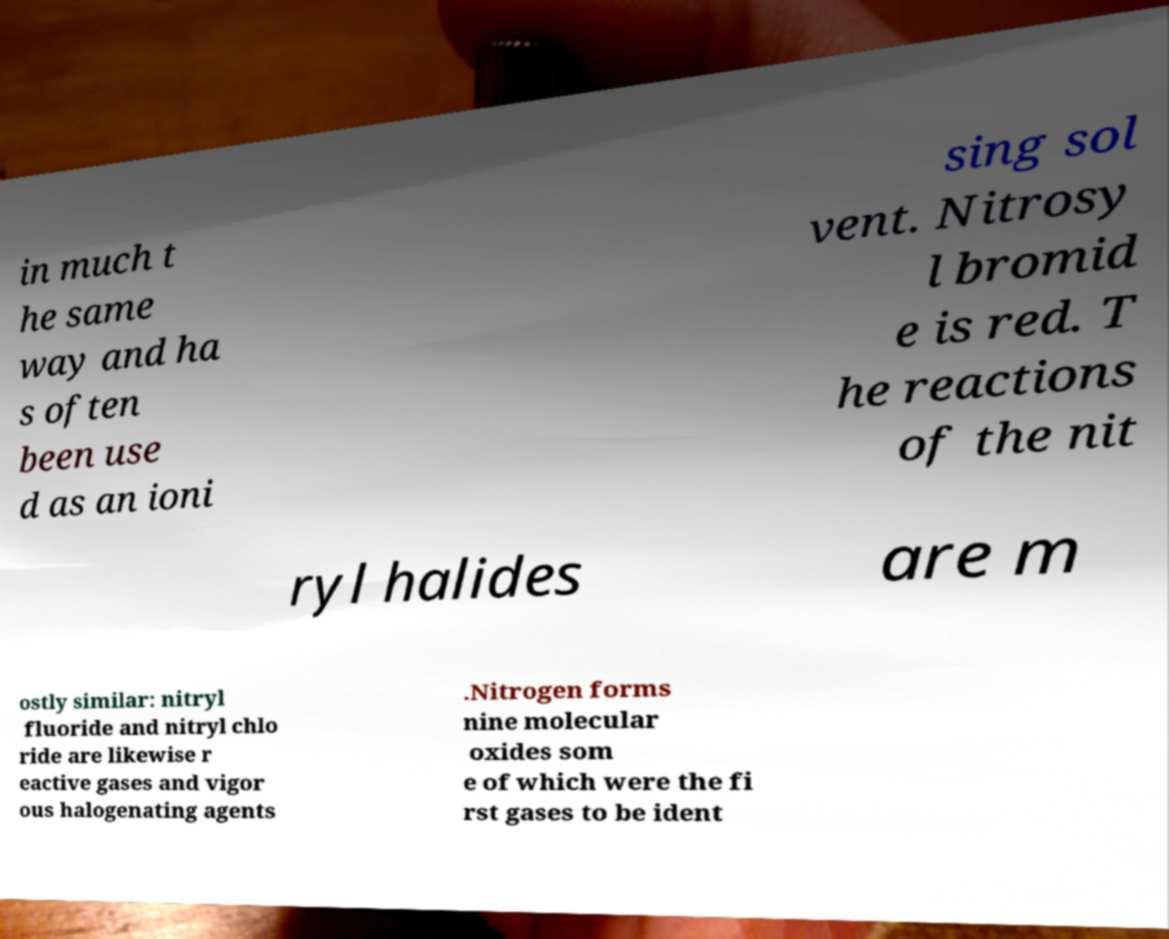Please read and relay the text visible in this image. What does it say? in much t he same way and ha s often been use d as an ioni sing sol vent. Nitrosy l bromid e is red. T he reactions of the nit ryl halides are m ostly similar: nitryl fluoride and nitryl chlo ride are likewise r eactive gases and vigor ous halogenating agents .Nitrogen forms nine molecular oxides som e of which were the fi rst gases to be ident 